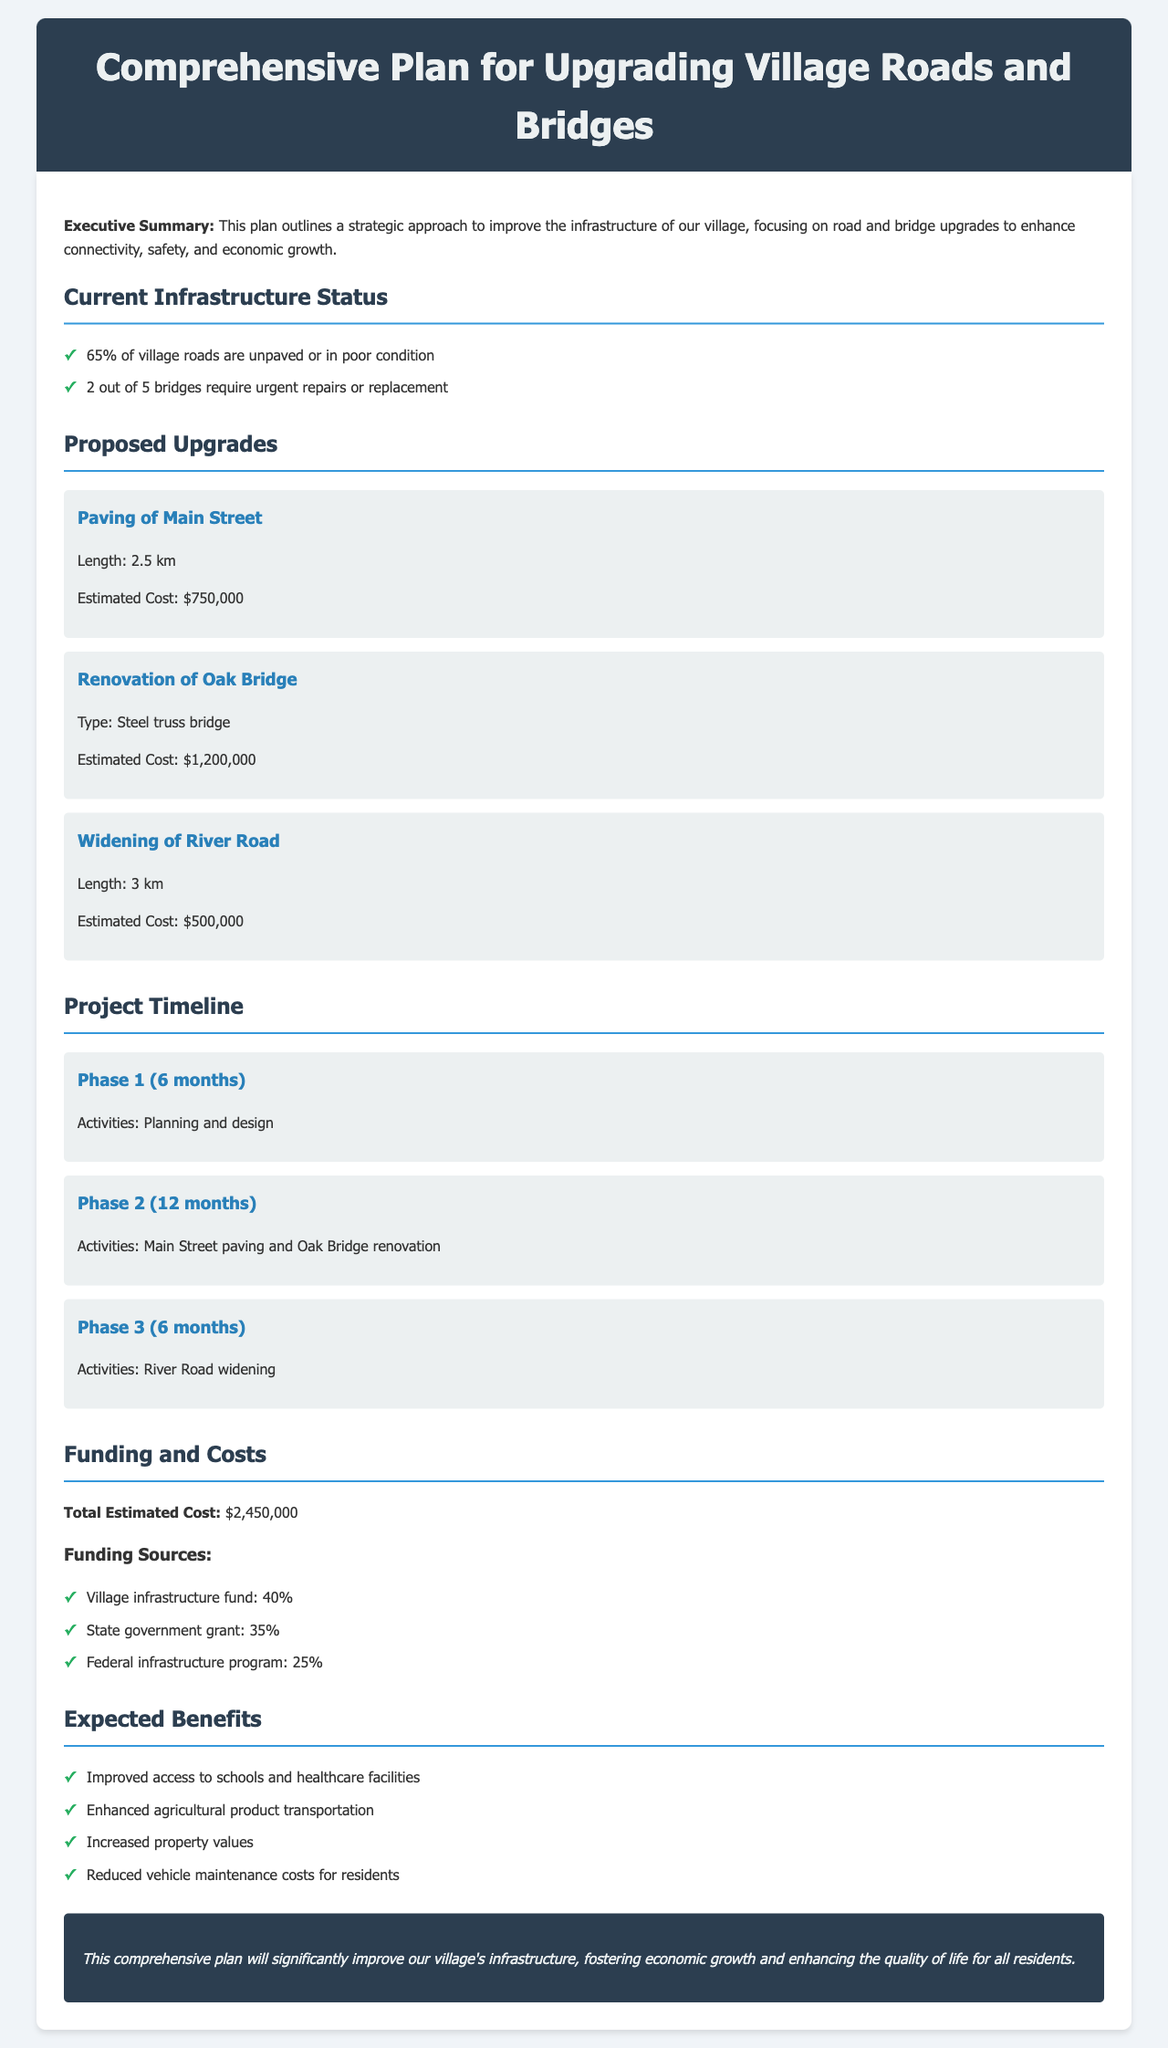What percentage of village roads are in poor condition? The document states that 65% of village roads are unpaved or in poor condition.
Answer: 65% What is the estimated cost for renovating Oak Bridge? The document provides the estimated cost for the renovation of Oak Bridge as $1,200,000.
Answer: $1,200,000 How long will the River Road widening take? The document indicates that the River Road widening is scheduled for 6 months in Phase 3.
Answer: 6 months What is the total estimated cost for the infrastructure upgrades? The document outlines the total estimated cost for the upgrades as $2,450,000.
Answer: $2,450,000 Which funding source contributes 35%? The document lists the state government grant as contributing 35% to the funding.
Answer: State government grant What are the expected benefits mentioned regarding property values? The expected benefit is an increase in property values as stated in the benefits section of the document.
Answer: Increased property values What activities are planned for Phase 2? The planned activities for Phase 2 include paving Main Street and renovating Oak Bridge.
Answer: Main Street paving and Oak Bridge renovation What is the name of the document? The title of the document is "Comprehensive Plan for Upgrading Village Roads and Bridges."
Answer: Comprehensive Plan for Upgrading Village Roads and Bridges 